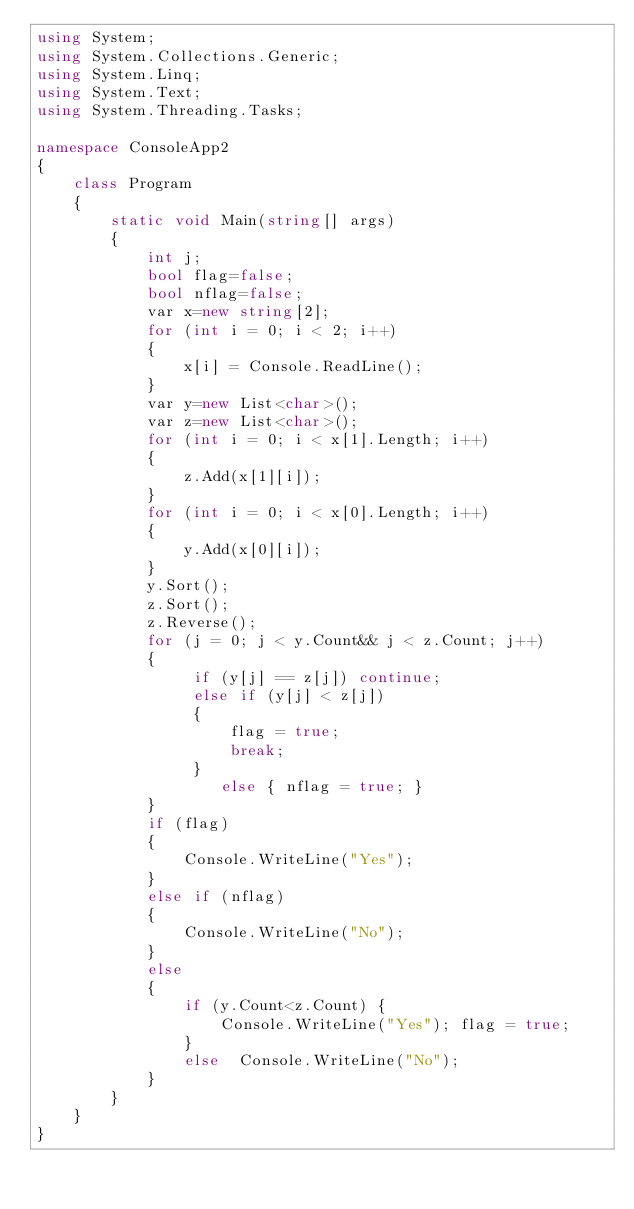<code> <loc_0><loc_0><loc_500><loc_500><_C#_>using System;
using System.Collections.Generic;
using System.Linq;
using System.Text;
using System.Threading.Tasks;

namespace ConsoleApp2
{
    class Program
    {
        static void Main(string[] args)
        {
            int j;
            bool flag=false;
            bool nflag=false;
            var x=new string[2];
            for (int i = 0; i < 2; i++)
            {
                x[i] = Console.ReadLine();
            }
            var y=new List<char>();
            var z=new List<char>();
            for (int i = 0; i < x[1].Length; i++)
            {
                z.Add(x[1][i]);
            }
            for (int i = 0; i < x[0].Length; i++)
            {
                y.Add(x[0][i]);
            }
            y.Sort();
            z.Sort();
            z.Reverse();
            for (j = 0; j < y.Count&& j < z.Count; j++)
            {
                 if (y[j] == z[j]) continue;
                 else if (y[j] < z[j])
                 {
                     flag = true;
                     break;
                 }
                    else { nflag = true; }
            }
            if (flag)
            {
                Console.WriteLine("Yes");
            }
            else if (nflag)
            {
                Console.WriteLine("No");
            }
            else
            {
                if (y.Count<z.Count) {
                    Console.WriteLine("Yes"); flag = true;
                }
                else  Console.WriteLine("No");
            }
        }
    }
}
</code> 